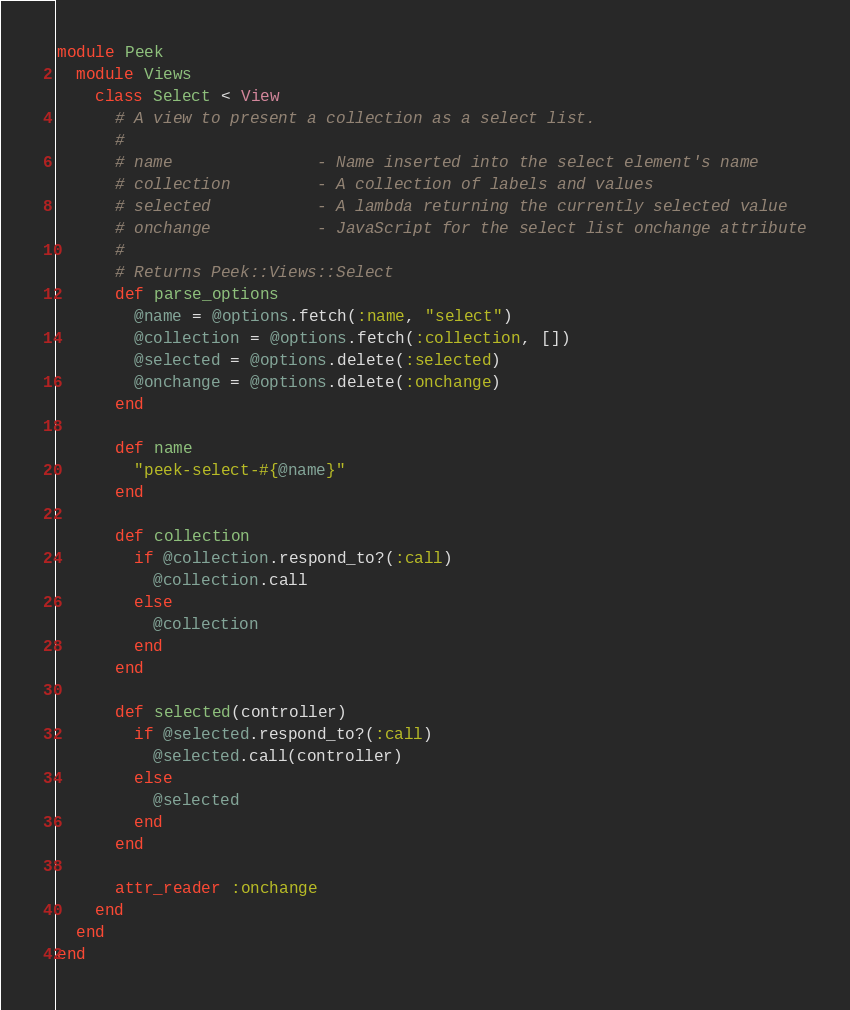<code> <loc_0><loc_0><loc_500><loc_500><_Ruby_>module Peek
  module Views
    class Select < View
      # A view to present a collection as a select list.
      #
      # name               - Name inserted into the select element's name
      # collection         - A collection of labels and values
      # selected           - A lambda returning the currently selected value
      # onchange           - JavaScript for the select list onchange attribute
      #
      # Returns Peek::Views::Select
      def parse_options
        @name = @options.fetch(:name, "select")
        @collection = @options.fetch(:collection, [])
        @selected = @options.delete(:selected)
        @onchange = @options.delete(:onchange)
      end

      def name
        "peek-select-#{@name}"
      end

      def collection
        if @collection.respond_to?(:call)
          @collection.call
        else
          @collection
        end
      end

      def selected(controller)
        if @selected.respond_to?(:call)
          @selected.call(controller)
        else
          @selected
        end
      end

      attr_reader :onchange
    end
  end
end
</code> 